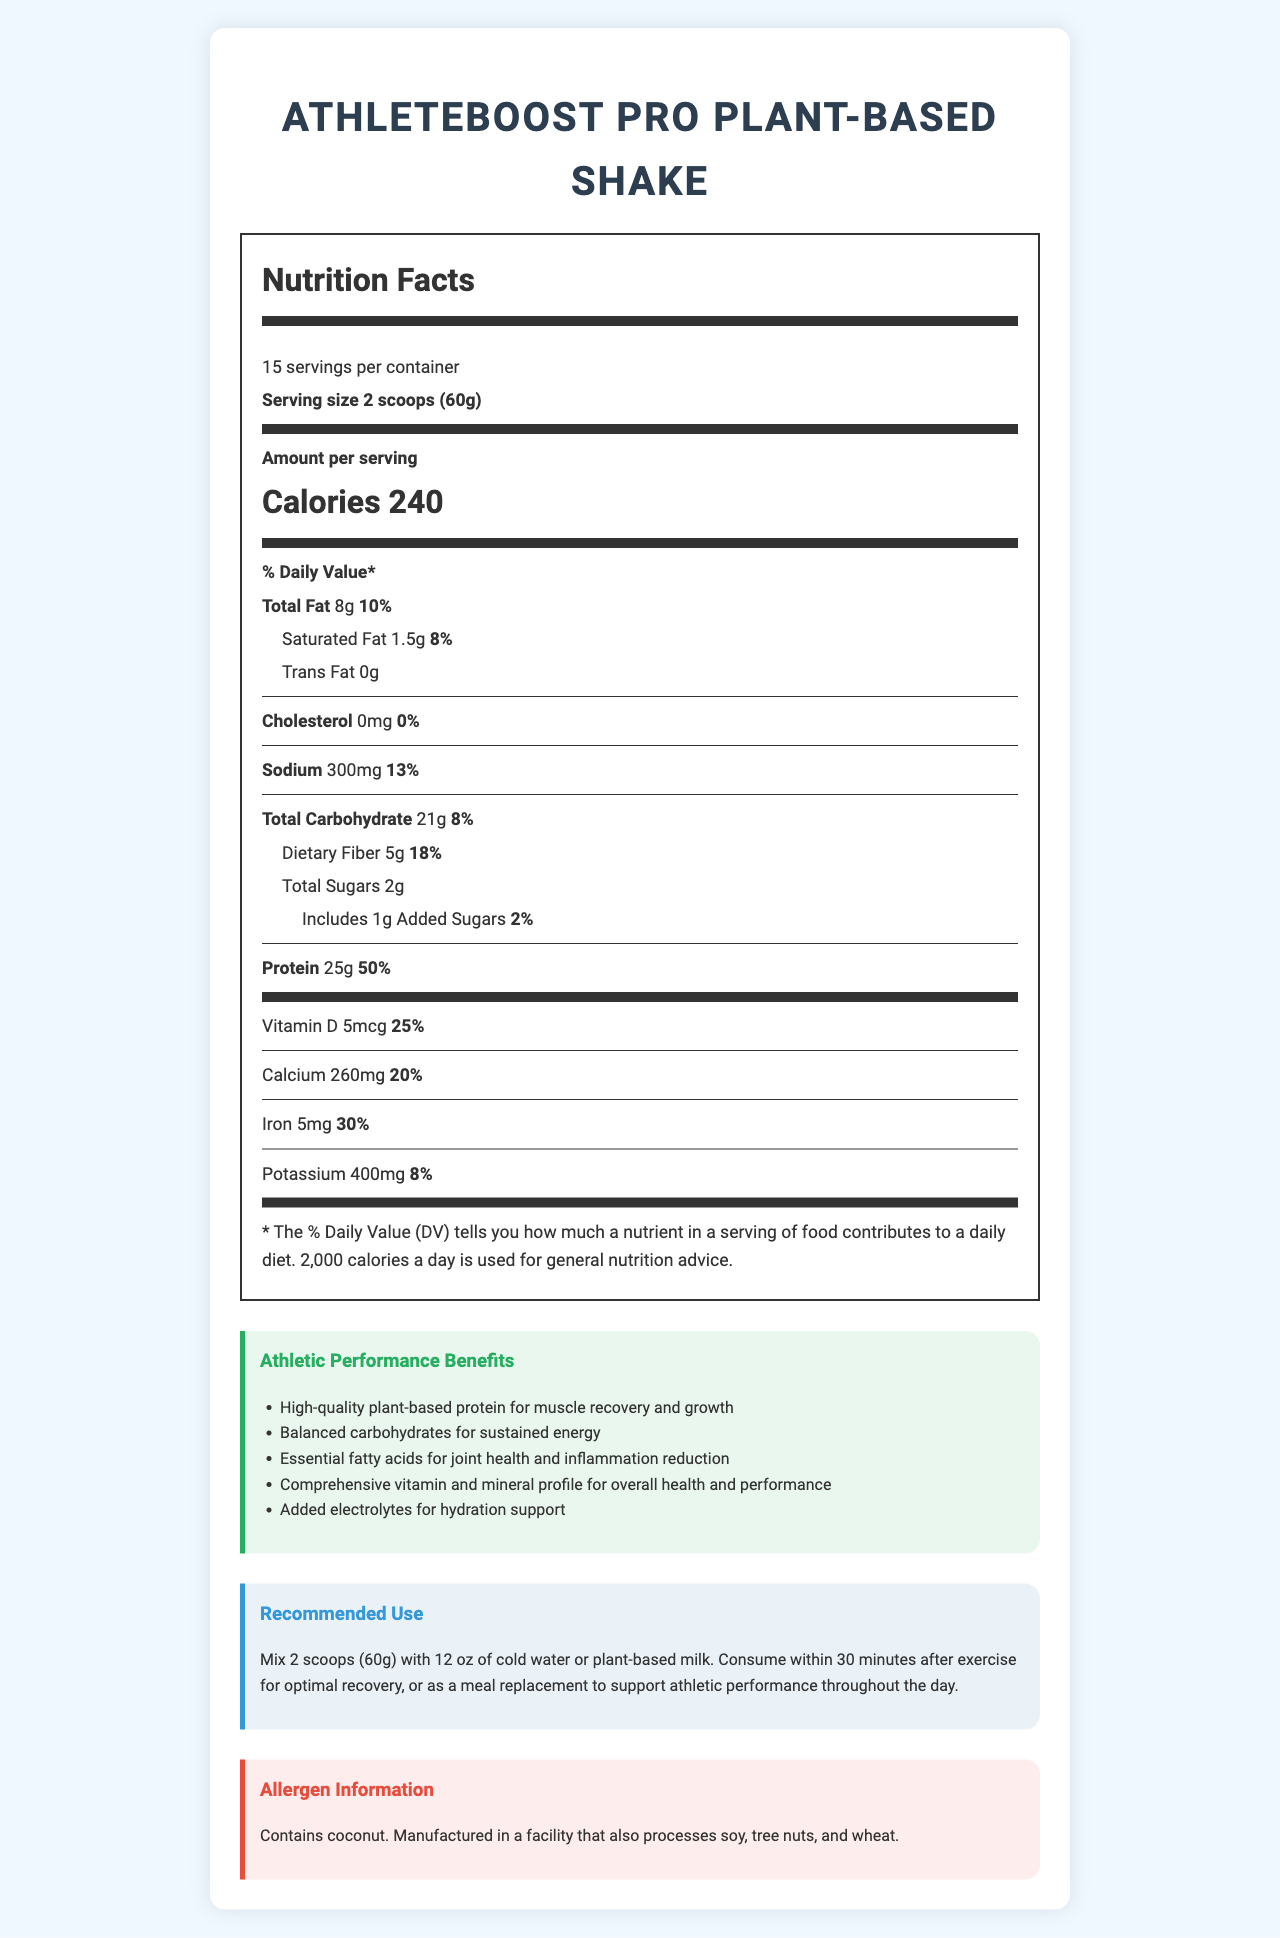what is the serving size? The document clearly states the serving size as "2 scoops (60g)".
Answer: 2 scoops (60g) how many calories are in one serving? The document states that each serving contains 240 calories.
Answer: 240 what is the protein content per serving? The document lists the protein content per serving as 25g.
Answer: 25g how much dietary fiber does each serving contain? The document specifies that each serving contains 5g of dietary fiber.
Answer: 5g does this shake contain any cholesterol? The document states that the cholesterol amount is 0mg, which means it does not contain any cholesterol.
Answer: No what type of protein is used in the shake? A. Whey Protein B. Soy Protein C. Pea Protein Isolate D. Casein Protein The ingredients list includes "Pea Protein Isolate" as one of the protein sources.
Answer: C what are the main benefits of this shake for athletes? (Choose all that apply) I. Muscle recovery II. Brain health III. Joint health IV. Sustained energy The document lists benefits for athletic performance: "High-quality plant-based protein for muscle recovery," "Balanced carbohydrates for sustained energy," and "Essential fatty acids for joint health and inflammation reduction."
Answer: I, III, IV does this product contain soy? The allergen information states that it contains coconut and is processed in a facility that also processes soy but does not declare soy as an ingredient.
Answer: No summarize the main idea of this document. The document describes the nutritional composition, benefits for athletic performance, recommended usage, and allergen information of the AthleteBoost Pro Plant-Based Shake, emphasizing its balance of macronutrients and micronutrients for optimal athletic performance.
Answer: AthleteBoost Pro Plant-Based Shake offers a balanced combination of macronutrients and micronutrients, ideal for athletic performance by providing high-quality plant-based protein for muscle recovery, balanced carbs for energy, essential fatty acids for joint health, a comprehensive vitamin, and mineral profile, and added electrolytes for hydration support. The shake also has clear servings, nutrition facts, benefits, recommended use, and allergen information. how much vitamin B12 is in each serving? The document lists vitamin B12 content per serving as 2.4mcg.
Answer: 2.4mcg what percentage daily value of iron does this shake provide? The document states that the iron content per serving is 30% of the daily value.
Answer: 30% how many servings are in one container? The document specifies that there are 15 servings per container.
Answer: 15 does this product contain any artificial sweeteners? The ingredients list includes natural sweeteners such as Organic Stevia Leaf Extract and Monk Fruit Extract, but no artificial sweeteners.
Answer: No how much potassium does each serving have? The document lists the amount of potassium per serving as 400mg.
Answer: 400mg are there any allergens in this shake? The allergen information states that it contains coconut and is manufactured in a facility that also processes soy, tree nuts, and wheat.
Answer: Yes 